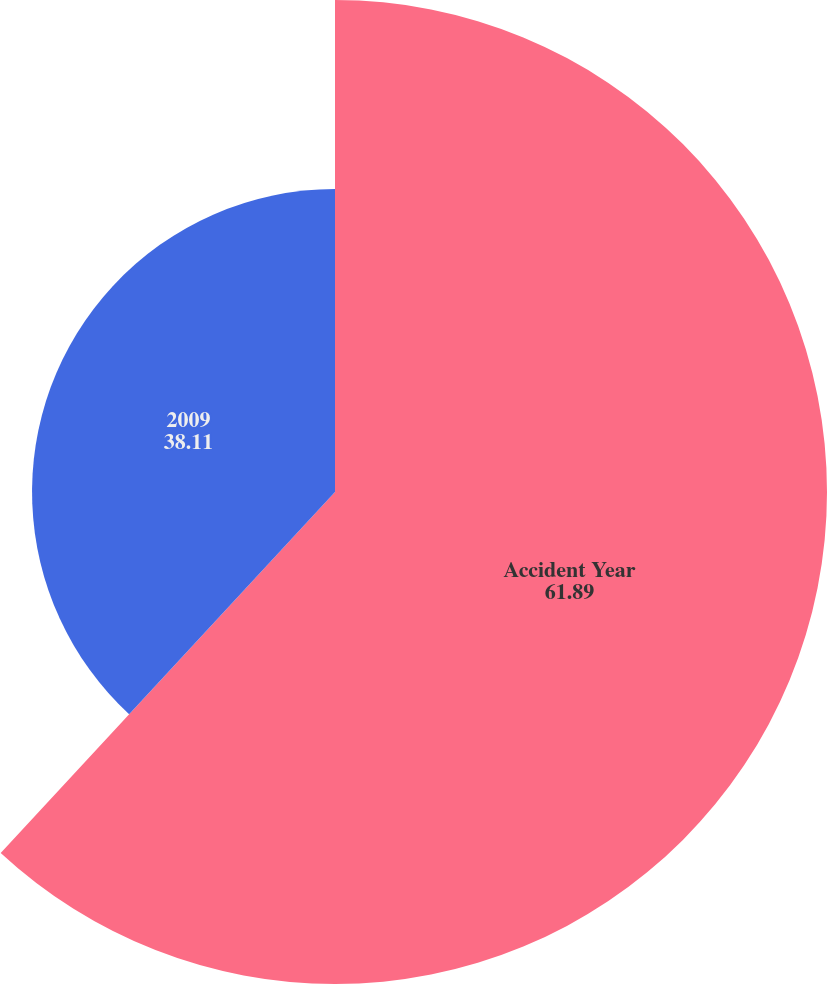Convert chart to OTSL. <chart><loc_0><loc_0><loc_500><loc_500><pie_chart><fcel>Accident Year<fcel>2009<nl><fcel>61.89%<fcel>38.11%<nl></chart> 